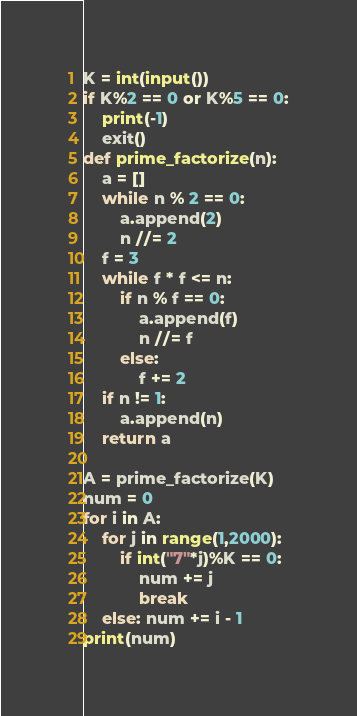Convert code to text. <code><loc_0><loc_0><loc_500><loc_500><_Python_>K = int(input())
if K%2 == 0 or K%5 == 0:
    print(-1)
    exit()
def prime_factorize(n):
    a = []
    while n % 2 == 0:
        a.append(2)
        n //= 2
    f = 3
    while f * f <= n:
        if n % f == 0:
            a.append(f)
            n //= f
        else:
            f += 2
    if n != 1:
        a.append(n)
    return a

A = prime_factorize(K)
num = 0
for i in A:
    for j in range(1,2000):
        if int("7"*j)%K == 0:
            num += j
            break
    else: num += i - 1
print(num)</code> 